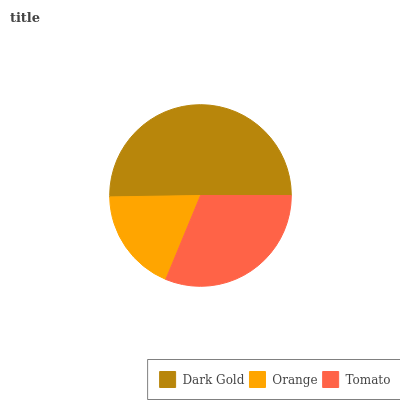Is Orange the minimum?
Answer yes or no. Yes. Is Dark Gold the maximum?
Answer yes or no. Yes. Is Tomato the minimum?
Answer yes or no. No. Is Tomato the maximum?
Answer yes or no. No. Is Tomato greater than Orange?
Answer yes or no. Yes. Is Orange less than Tomato?
Answer yes or no. Yes. Is Orange greater than Tomato?
Answer yes or no. No. Is Tomato less than Orange?
Answer yes or no. No. Is Tomato the high median?
Answer yes or no. Yes. Is Tomato the low median?
Answer yes or no. Yes. Is Orange the high median?
Answer yes or no. No. Is Orange the low median?
Answer yes or no. No. 